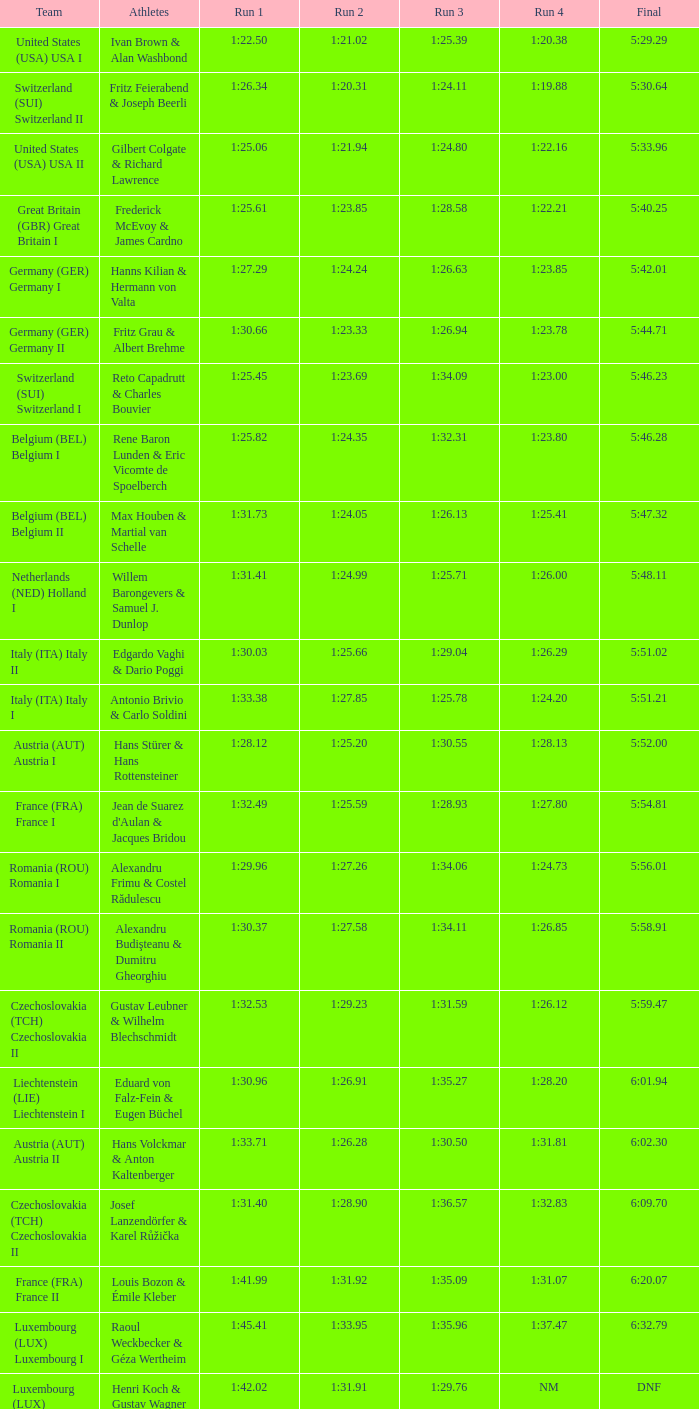Which Run 2 has a Run 1 of 1:30.03? 1:25.66. 